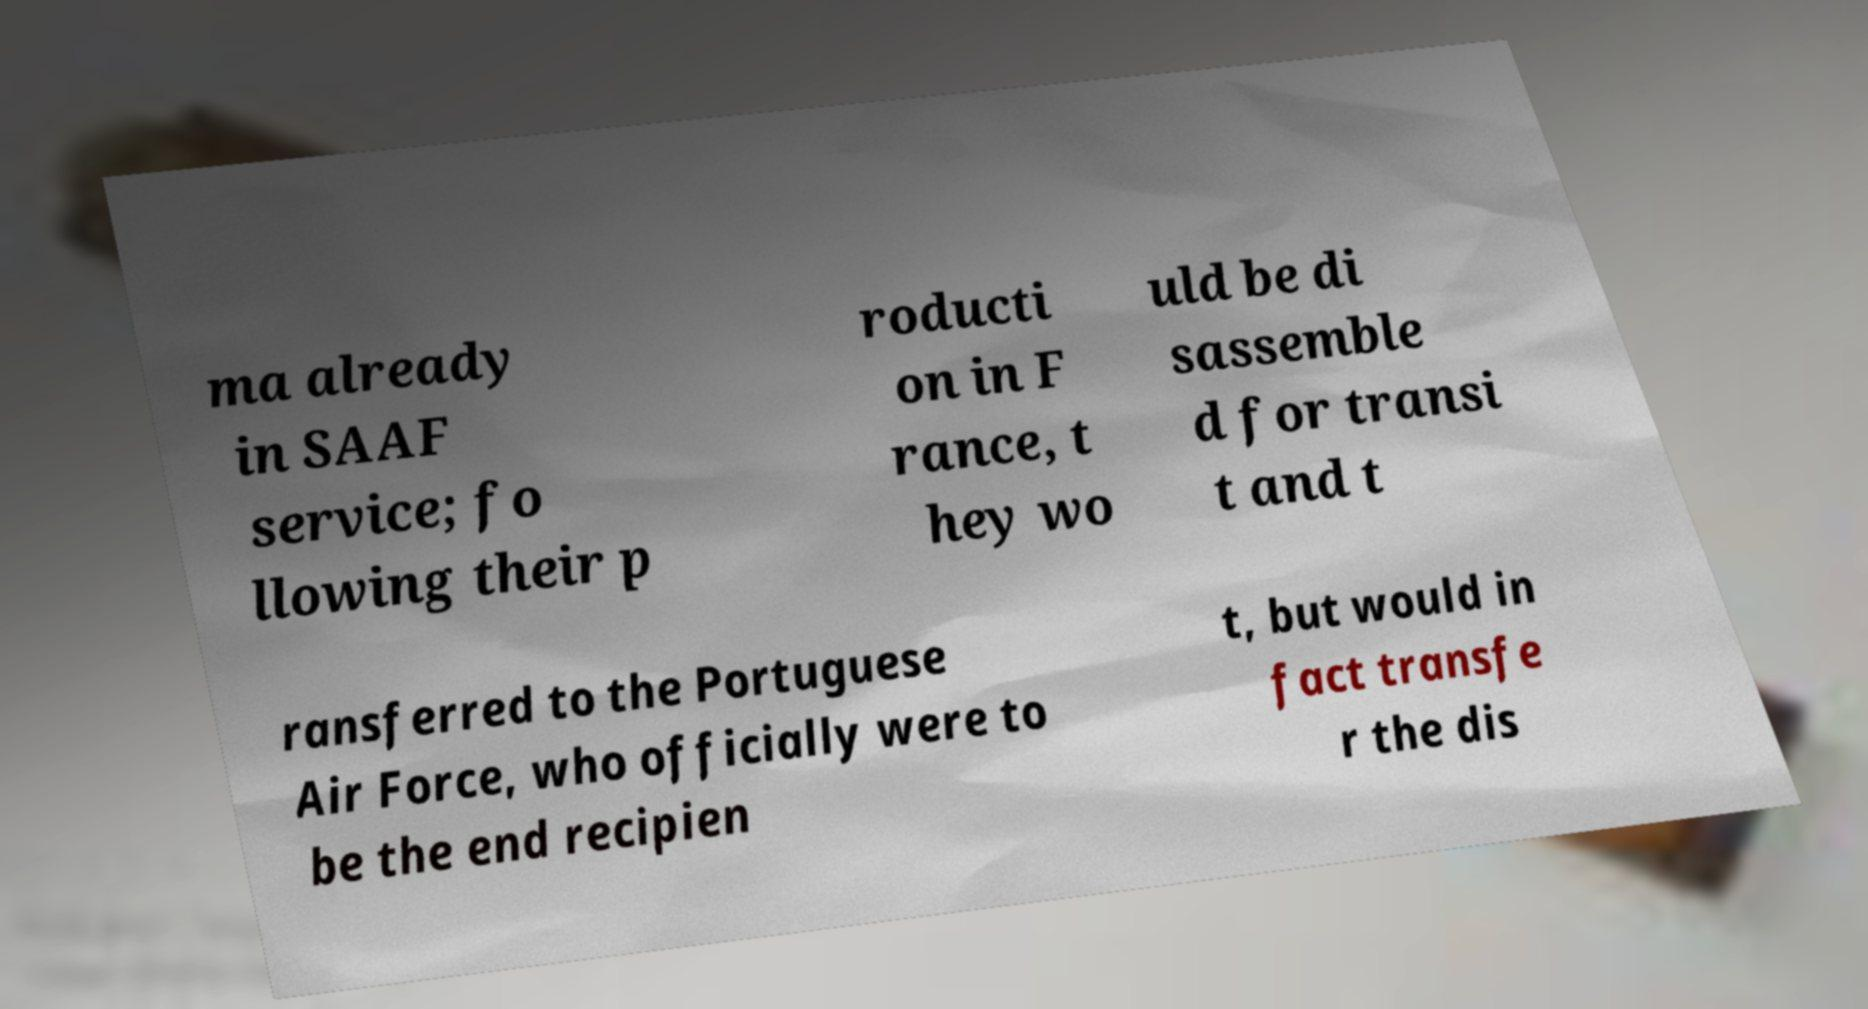What messages or text are displayed in this image? I need them in a readable, typed format. ma already in SAAF service; fo llowing their p roducti on in F rance, t hey wo uld be di sassemble d for transi t and t ransferred to the Portuguese Air Force, who officially were to be the end recipien t, but would in fact transfe r the dis 